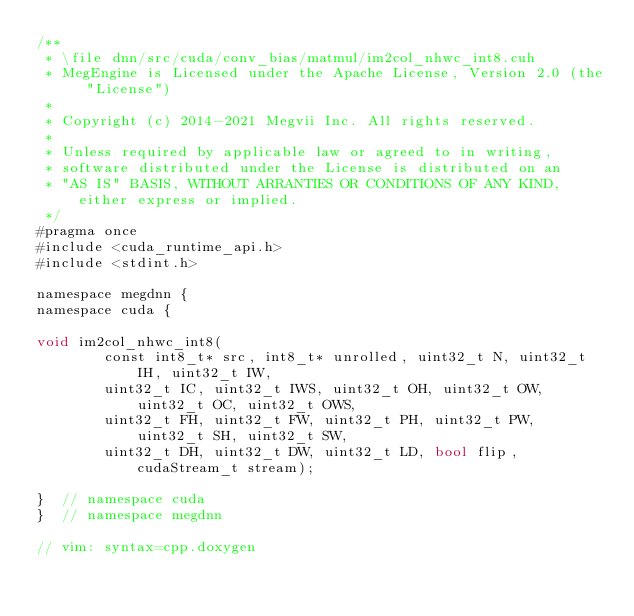Convert code to text. <code><loc_0><loc_0><loc_500><loc_500><_Cuda_>/**
 * \file dnn/src/cuda/conv_bias/matmul/im2col_nhwc_int8.cuh
 * MegEngine is Licensed under the Apache License, Version 2.0 (the "License")
 *
 * Copyright (c) 2014-2021 Megvii Inc. All rights reserved.
 *
 * Unless required by applicable law or agreed to in writing,
 * software distributed under the License is distributed on an
 * "AS IS" BASIS, WITHOUT ARRANTIES OR CONDITIONS OF ANY KIND, either express or implied.
 */
#pragma once
#include <cuda_runtime_api.h>
#include <stdint.h>

namespace megdnn {
namespace cuda {

void im2col_nhwc_int8(
        const int8_t* src, int8_t* unrolled, uint32_t N, uint32_t IH, uint32_t IW,
        uint32_t IC, uint32_t IWS, uint32_t OH, uint32_t OW, uint32_t OC, uint32_t OWS,
        uint32_t FH, uint32_t FW, uint32_t PH, uint32_t PW, uint32_t SH, uint32_t SW,
        uint32_t DH, uint32_t DW, uint32_t LD, bool flip, cudaStream_t stream);

}  // namespace cuda
}  // namespace megdnn

// vim: syntax=cpp.doxygen
</code> 